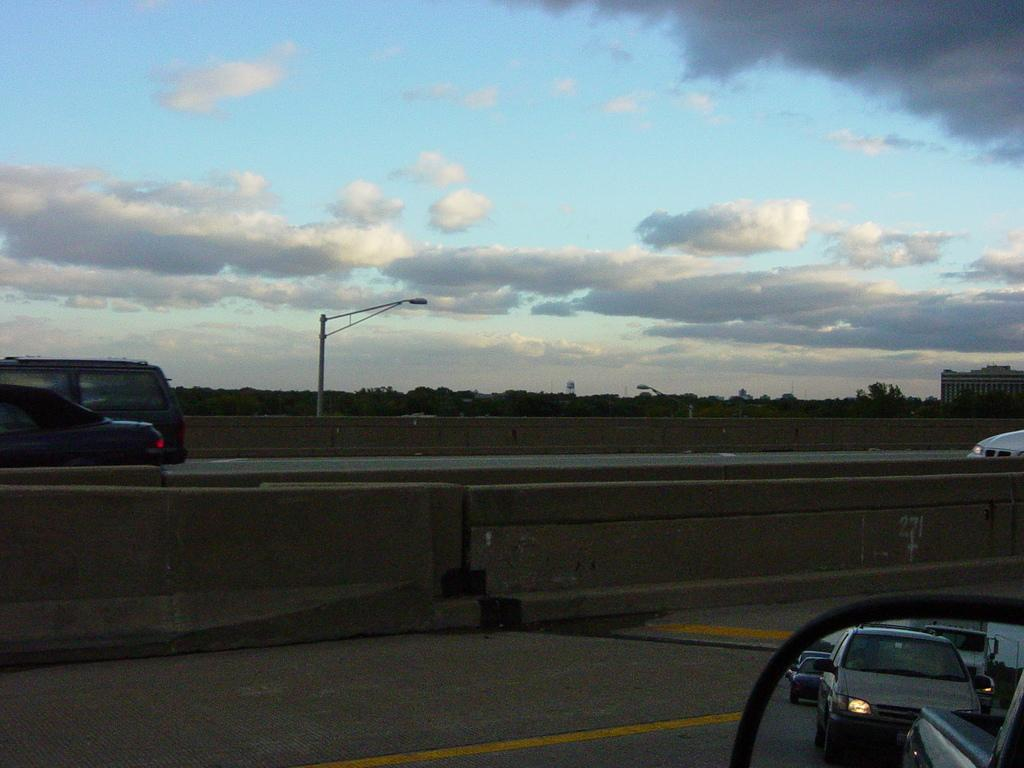What is happening on the road in the image? There are vehicles moving on the road in the image. What can be seen in the background of the image? There are trees, a street light, and a building in the background of the image. What is the condition of the sky in the image? The sky is cloudy in the image. How many gloves can be seen on the wrist of the person in the image? There is no person or glove present in the image. What type of trains are visible in the image? There are no trains visible in the image; it features vehicles moving on the road. 